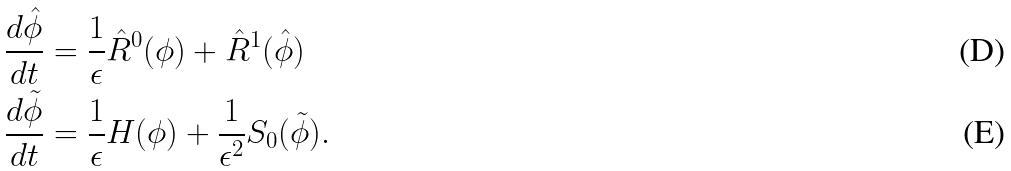<formula> <loc_0><loc_0><loc_500><loc_500>\frac { d \hat { \phi } } { d t } & = \frac { 1 } { \epsilon } \hat { R } ^ { 0 } ( \phi ) + \hat { R } ^ { 1 } ( \hat { \phi } ) \\ \frac { d \tilde { \phi } } { d t } & = \frac { 1 } { \epsilon } H ( \phi ) + \frac { 1 } { { \epsilon } ^ { 2 } } S _ { 0 } ( \tilde { \phi } ) .</formula> 